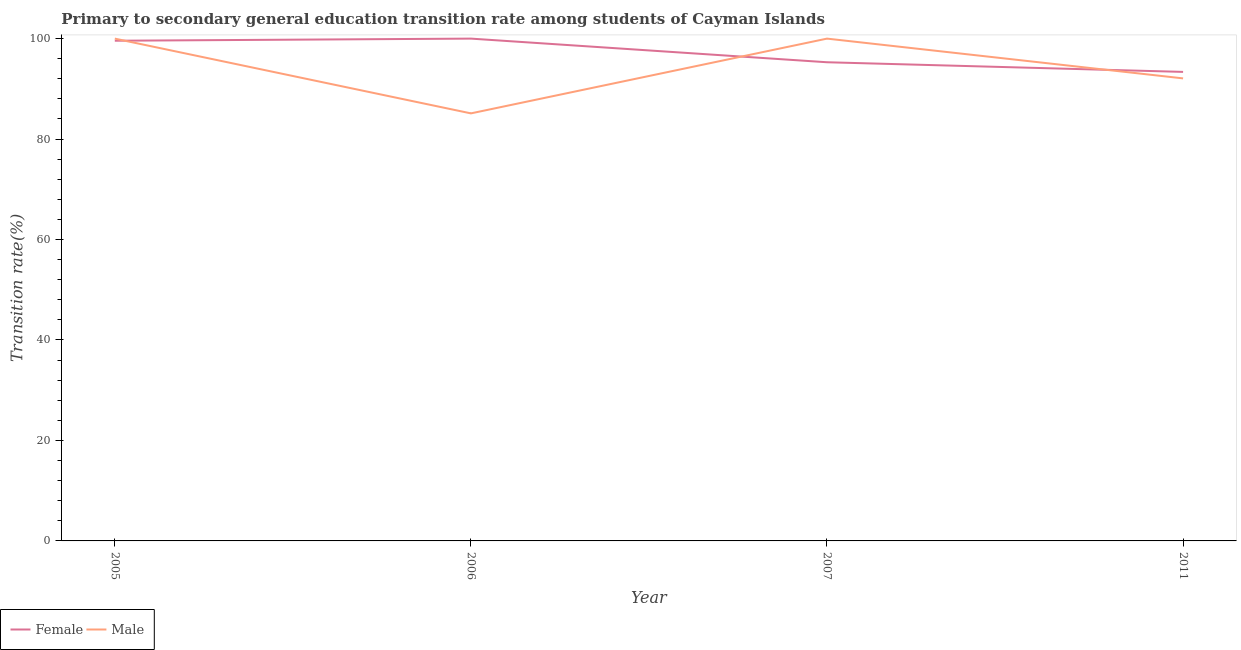Does the line corresponding to transition rate among female students intersect with the line corresponding to transition rate among male students?
Offer a very short reply. Yes. What is the transition rate among female students in 2011?
Keep it short and to the point. 93.37. Across all years, what is the minimum transition rate among female students?
Give a very brief answer. 93.37. In which year was the transition rate among male students minimum?
Give a very brief answer. 2006. What is the total transition rate among female students in the graph?
Your answer should be compact. 388.24. What is the difference between the transition rate among male students in 2006 and that in 2011?
Offer a terse response. -6.97. What is the difference between the transition rate among male students in 2005 and the transition rate among female students in 2007?
Your answer should be very brief. 4.71. What is the average transition rate among female students per year?
Ensure brevity in your answer.  97.06. In the year 2005, what is the difference between the transition rate among female students and transition rate among male students?
Your answer should be very brief. -0.42. In how many years, is the transition rate among male students greater than 76 %?
Give a very brief answer. 4. What is the ratio of the transition rate among male students in 2006 to that in 2011?
Make the answer very short. 0.92. Is the transition rate among male students in 2006 less than that in 2007?
Offer a very short reply. Yes. What is the difference between the highest and the second highest transition rate among male students?
Your answer should be very brief. 0. What is the difference between the highest and the lowest transition rate among male students?
Keep it short and to the point. 14.88. In how many years, is the transition rate among female students greater than the average transition rate among female students taken over all years?
Your answer should be compact. 2. Is the sum of the transition rate among female students in 2005 and 2006 greater than the maximum transition rate among male students across all years?
Offer a very short reply. Yes. Is the transition rate among female students strictly greater than the transition rate among male students over the years?
Provide a succinct answer. No. Are the values on the major ticks of Y-axis written in scientific E-notation?
Your response must be concise. No. Does the graph contain grids?
Your response must be concise. No. Where does the legend appear in the graph?
Give a very brief answer. Bottom left. How many legend labels are there?
Provide a short and direct response. 2. How are the legend labels stacked?
Your answer should be compact. Horizontal. What is the title of the graph?
Ensure brevity in your answer.  Primary to secondary general education transition rate among students of Cayman Islands. Does "Highest 20% of population" appear as one of the legend labels in the graph?
Keep it short and to the point. No. What is the label or title of the X-axis?
Keep it short and to the point. Year. What is the label or title of the Y-axis?
Keep it short and to the point. Transition rate(%). What is the Transition rate(%) of Female in 2005?
Make the answer very short. 99.58. What is the Transition rate(%) in Male in 2005?
Your answer should be very brief. 100. What is the Transition rate(%) in Male in 2006?
Your response must be concise. 85.12. What is the Transition rate(%) of Female in 2007?
Keep it short and to the point. 95.29. What is the Transition rate(%) in Male in 2007?
Provide a succinct answer. 100. What is the Transition rate(%) of Female in 2011?
Give a very brief answer. 93.37. What is the Transition rate(%) of Male in 2011?
Keep it short and to the point. 92.08. Across all years, what is the maximum Transition rate(%) of Female?
Provide a succinct answer. 100. Across all years, what is the minimum Transition rate(%) in Female?
Give a very brief answer. 93.37. Across all years, what is the minimum Transition rate(%) of Male?
Ensure brevity in your answer.  85.12. What is the total Transition rate(%) of Female in the graph?
Provide a succinct answer. 388.24. What is the total Transition rate(%) of Male in the graph?
Provide a short and direct response. 377.2. What is the difference between the Transition rate(%) of Female in 2005 and that in 2006?
Offer a terse response. -0.42. What is the difference between the Transition rate(%) of Male in 2005 and that in 2006?
Make the answer very short. 14.88. What is the difference between the Transition rate(%) of Female in 2005 and that in 2007?
Provide a succinct answer. 4.28. What is the difference between the Transition rate(%) in Male in 2005 and that in 2007?
Give a very brief answer. 0. What is the difference between the Transition rate(%) in Female in 2005 and that in 2011?
Your response must be concise. 6.2. What is the difference between the Transition rate(%) of Male in 2005 and that in 2011?
Offer a terse response. 7.92. What is the difference between the Transition rate(%) of Female in 2006 and that in 2007?
Make the answer very short. 4.71. What is the difference between the Transition rate(%) of Male in 2006 and that in 2007?
Ensure brevity in your answer.  -14.88. What is the difference between the Transition rate(%) of Female in 2006 and that in 2011?
Ensure brevity in your answer.  6.63. What is the difference between the Transition rate(%) in Male in 2006 and that in 2011?
Make the answer very short. -6.97. What is the difference between the Transition rate(%) in Female in 2007 and that in 2011?
Make the answer very short. 1.92. What is the difference between the Transition rate(%) of Male in 2007 and that in 2011?
Ensure brevity in your answer.  7.92. What is the difference between the Transition rate(%) in Female in 2005 and the Transition rate(%) in Male in 2006?
Make the answer very short. 14.46. What is the difference between the Transition rate(%) in Female in 2005 and the Transition rate(%) in Male in 2007?
Provide a succinct answer. -0.42. What is the difference between the Transition rate(%) of Female in 2005 and the Transition rate(%) of Male in 2011?
Give a very brief answer. 7.5. What is the difference between the Transition rate(%) of Female in 2006 and the Transition rate(%) of Male in 2011?
Your response must be concise. 7.92. What is the difference between the Transition rate(%) of Female in 2007 and the Transition rate(%) of Male in 2011?
Provide a succinct answer. 3.21. What is the average Transition rate(%) of Female per year?
Make the answer very short. 97.06. What is the average Transition rate(%) of Male per year?
Offer a very short reply. 94.3. In the year 2005, what is the difference between the Transition rate(%) in Female and Transition rate(%) in Male?
Ensure brevity in your answer.  -0.42. In the year 2006, what is the difference between the Transition rate(%) in Female and Transition rate(%) in Male?
Keep it short and to the point. 14.88. In the year 2007, what is the difference between the Transition rate(%) in Female and Transition rate(%) in Male?
Offer a terse response. -4.71. In the year 2011, what is the difference between the Transition rate(%) in Female and Transition rate(%) in Male?
Keep it short and to the point. 1.29. What is the ratio of the Transition rate(%) in Male in 2005 to that in 2006?
Keep it short and to the point. 1.17. What is the ratio of the Transition rate(%) of Female in 2005 to that in 2007?
Make the answer very short. 1.04. What is the ratio of the Transition rate(%) of Female in 2005 to that in 2011?
Offer a terse response. 1.07. What is the ratio of the Transition rate(%) of Male in 2005 to that in 2011?
Ensure brevity in your answer.  1.09. What is the ratio of the Transition rate(%) in Female in 2006 to that in 2007?
Your answer should be very brief. 1.05. What is the ratio of the Transition rate(%) in Male in 2006 to that in 2007?
Keep it short and to the point. 0.85. What is the ratio of the Transition rate(%) of Female in 2006 to that in 2011?
Make the answer very short. 1.07. What is the ratio of the Transition rate(%) of Male in 2006 to that in 2011?
Offer a very short reply. 0.92. What is the ratio of the Transition rate(%) in Female in 2007 to that in 2011?
Your response must be concise. 1.02. What is the ratio of the Transition rate(%) in Male in 2007 to that in 2011?
Offer a terse response. 1.09. What is the difference between the highest and the second highest Transition rate(%) in Female?
Make the answer very short. 0.42. What is the difference between the highest and the second highest Transition rate(%) in Male?
Keep it short and to the point. 0. What is the difference between the highest and the lowest Transition rate(%) in Female?
Your answer should be very brief. 6.63. What is the difference between the highest and the lowest Transition rate(%) of Male?
Give a very brief answer. 14.88. 